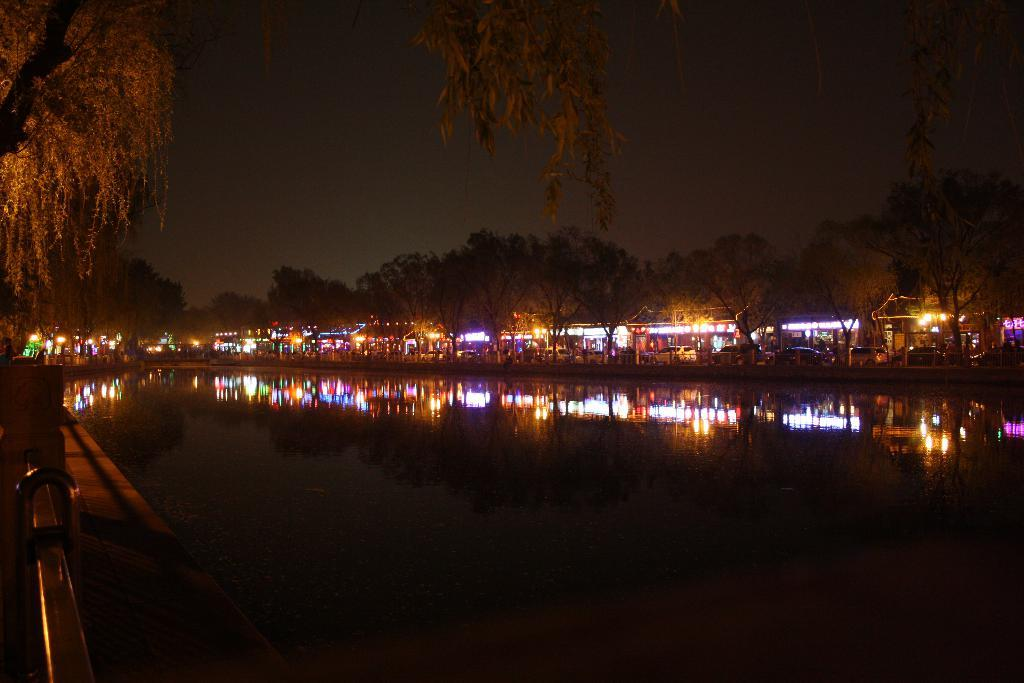What is the main subject in the center of the image? There is water in the center of the image. What can be seen in the background of the image? The sky, clouds, trees, buildings, and lights are visible in the background of the image. What grade did the kite receive in the image? There is no kite present in the image, so it cannot receive a grade. 